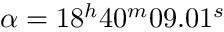Convert formula to latex. <formula><loc_0><loc_0><loc_500><loc_500>\alpha = 1 8 ^ { h } 4 0 ^ { m } 0 9 . 0 1 ^ { s }</formula> 